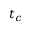<formula> <loc_0><loc_0><loc_500><loc_500>t _ { c }</formula> 